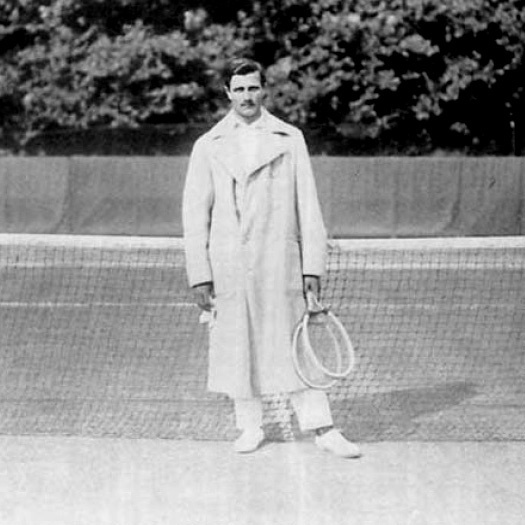Describe the objects in this image and their specific colors. I can see people in gray, lightgray, darkgray, and black tones, tennis racket in gray, darkgray, lightgray, and black tones, and tennis racket in lightgray, darkgray, and gray tones in this image. 